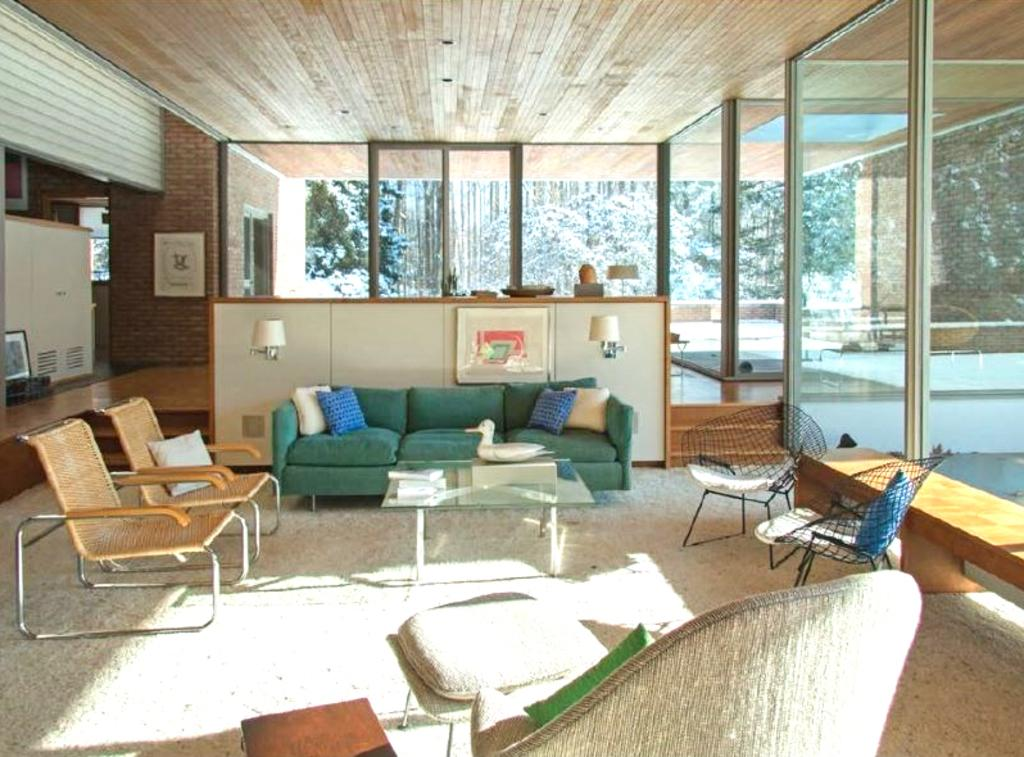What type of furniture is located on the left side of the image? There are chairs on the left side of the image. What piece of furniture is in the middle of the image? There is a sofa in the middle of the image. What kind of wall is on the right side of the image? There is a glass wall on the right side of the image. How many oranges are placed on the spoon in the image? There are no oranges or spoons present in the image. What type of beds can be seen in the image? There are no beds present in the image. 